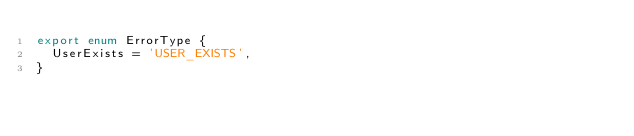<code> <loc_0><loc_0><loc_500><loc_500><_TypeScript_>export enum ErrorType {
  UserExists = 'USER_EXISTS',
}
</code> 